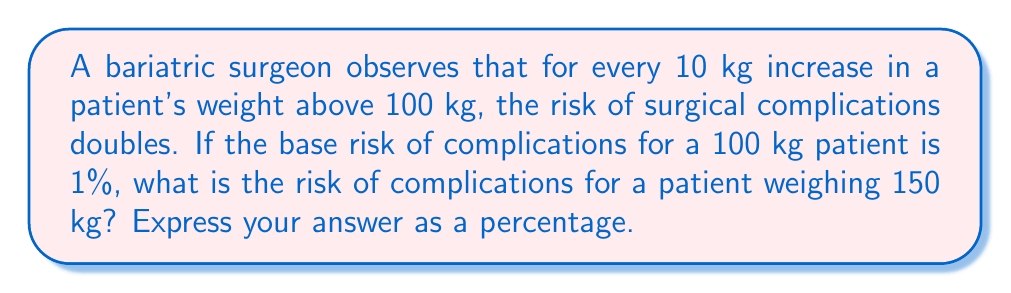Show me your answer to this math problem. Let's approach this step-by-step:

1) First, we need to determine how many 10 kg increments there are between 100 kg and 150 kg:
   $\frac{150 \text{ kg} - 100 \text{ kg}}{10 \text{ kg}} = 5$ increments

2) We're told that the risk doubles for each increment. This can be expressed as an exponential function:

   $\text{Risk} = 1\% \cdot 2^n$

   Where $n$ is the number of 10 kg increments above 100 kg.

3) In this case, $n = 5$, so we can write:

   $\text{Risk} = 1\% \cdot 2^5$

4) Let's calculate $2^5$:
   $2^5 = 2 \cdot 2 \cdot 2 \cdot 2 \cdot 2 = 32$

5) Now we can calculate the risk:

   $\text{Risk} = 1\% \cdot 32 = 0.01 \cdot 32 = 0.32$

6) To express this as a percentage, we multiply by 100:

   $0.32 \cdot 100 = 32\%$

Therefore, the risk of complications for a patient weighing 150 kg is 32%.
Answer: 32% 